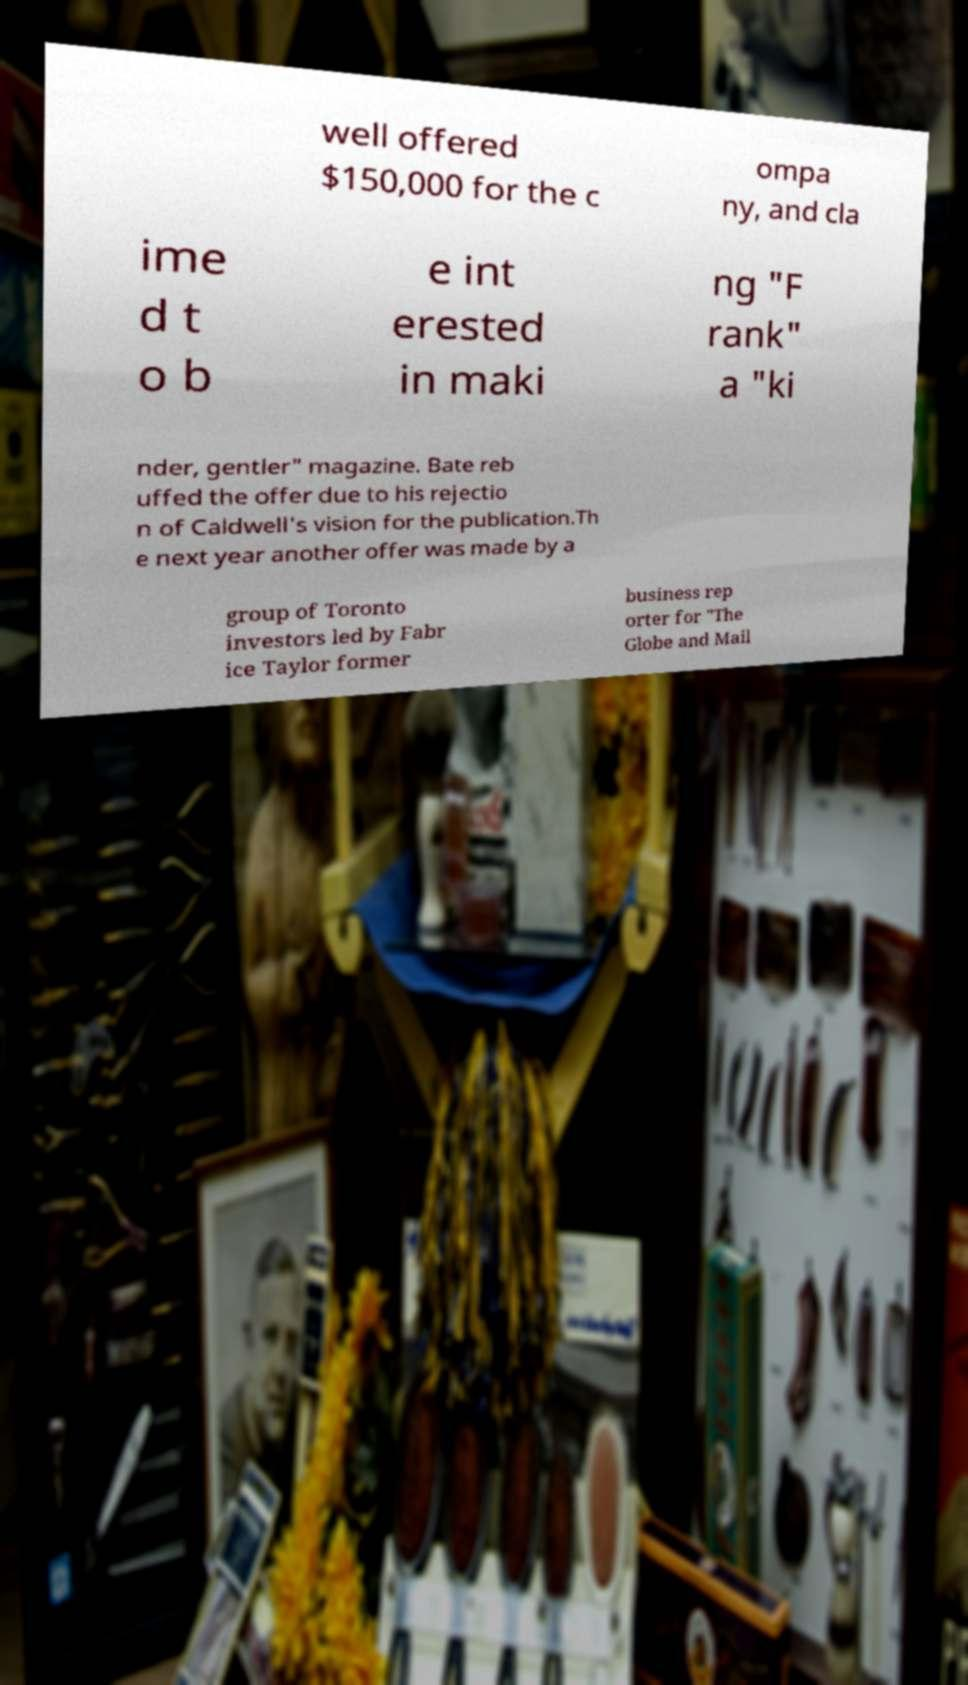For documentation purposes, I need the text within this image transcribed. Could you provide that? well offered $150,000 for the c ompa ny, and cla ime d t o b e int erested in maki ng "F rank" a "ki nder, gentler" magazine. Bate reb uffed the offer due to his rejectio n of Caldwell's vision for the publication.Th e next year another offer was made by a group of Toronto investors led by Fabr ice Taylor former business rep orter for "The Globe and Mail 